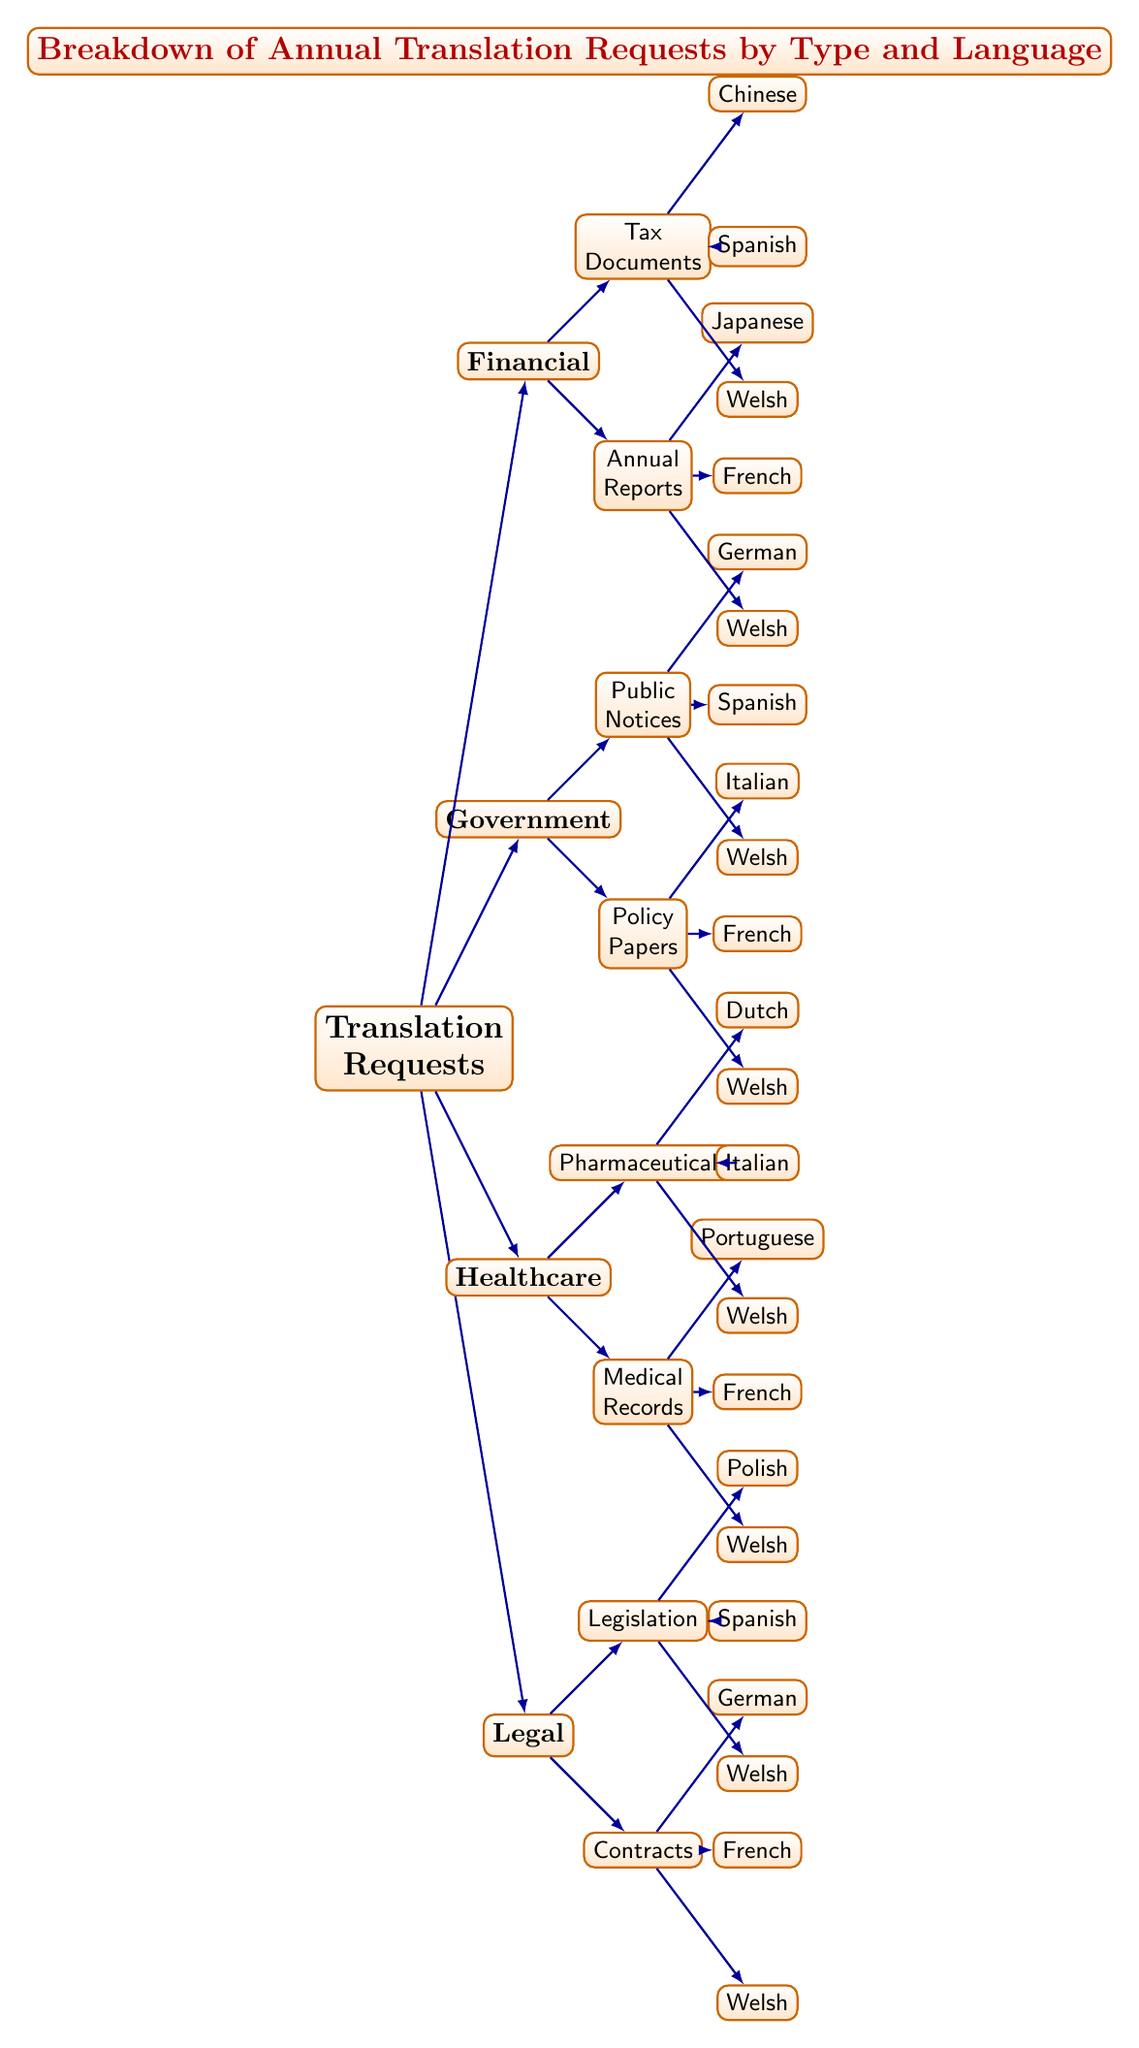What types of translation requests are present in the diagram? The diagram displays four main categories of translation requests: Legal, Healthcare, Government, and Financial. Each category represents a distinct area where translation is requested.
Answer: Legal, Healthcare, Government, Financial How many languages are associated with "Healthcare" translation requests? The "Healthcare" category has two subcategories: Medical Records and Pharmaceuticals. Each subcategory lists three languages, giving a total of six language requests.
Answer: Six Which language is associated with the "Legislation" category? The "Legislation" category includes Welsh, Spanish, and Polish as its associated languages. Selecting any of these languages will yield an answer based strictly on the provided diagram.
Answer: Welsh, Spanish, Polish What is the total number of subcategories under "Financial"? The "Financial" category has two subcategories: Annual Reports and Tax Documents, indicating there are a total of two subcategories.
Answer: Two Which translation request type has the most associated languages? By reviewing each translation request type and counting the languages listed, it becomes clear that "Medical Records" and "Policy Papers" each have three languages associated, indicating they have the highest count.
Answer: Medical Records, Policy Papers Which language is associated with both "Healthcare" and "Government"? Upon analyzing the intersections of requested languages within the diagram, Welsh appears under both the Healthcare and Government categories. This establishes Welsh as a common language across these categories.
Answer: Welsh What is the relationship between "Contracts" and "Legislation"? In the diagram, "Contracts" and "Legislation" are both categorized under the "Legal" type of translation requests. They are sibling nodes that share the same parent node (Legal).
Answer: Sibling nodes within Legal How many languages can you find associated with the "Public Notices" subcategory? The "Public Notices" subcategory explicitly lists three languages: Welsh, Spanish, and German, making it clear that there are three languages associated with this category.
Answer: Three 